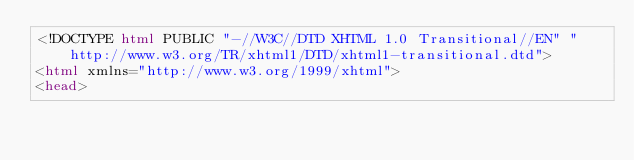<code> <loc_0><loc_0><loc_500><loc_500><_HTML_><!DOCTYPE html PUBLIC "-//W3C//DTD XHTML 1.0 Transitional//EN" "http://www.w3.org/TR/xhtml1/DTD/xhtml1-transitional.dtd">
<html xmlns="http://www.w3.org/1999/xhtml">
<head></code> 